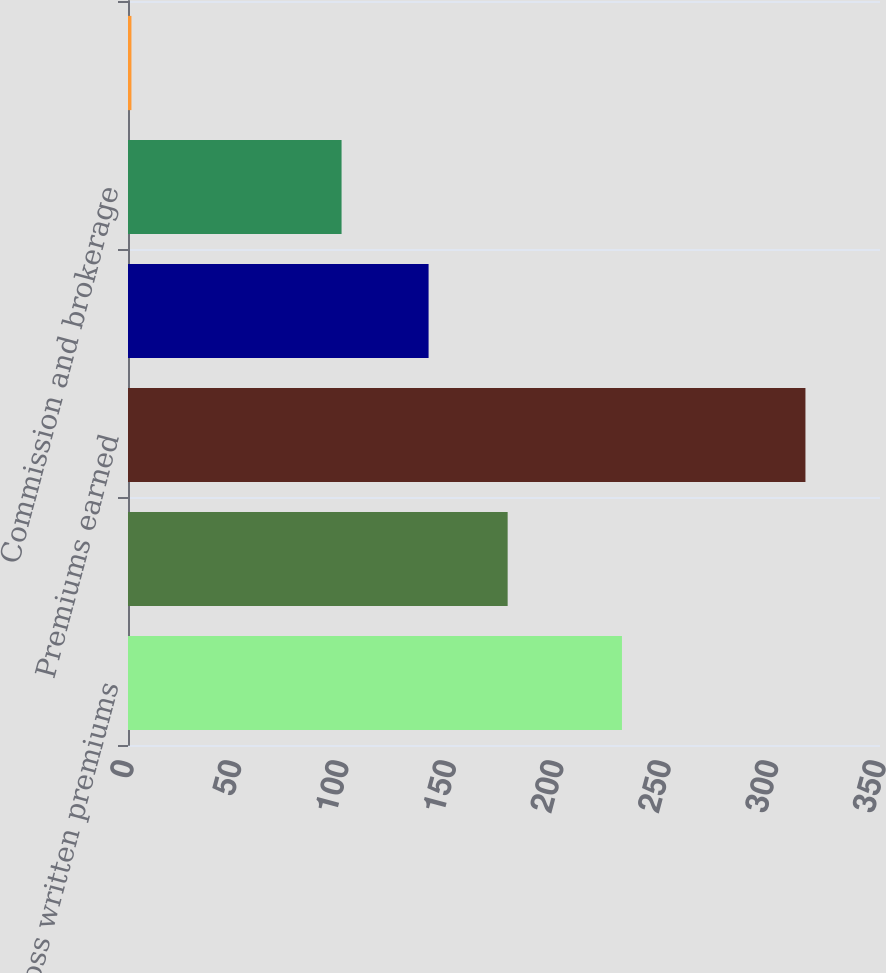Convert chart to OTSL. <chart><loc_0><loc_0><loc_500><loc_500><bar_chart><fcel>Gross written premiums<fcel>Net written premiums<fcel>Premiums earned<fcel>Incurred losses and LAE<fcel>Commission and brokerage<fcel>Other underwriting expenses<nl><fcel>229.9<fcel>176.7<fcel>315.3<fcel>139.9<fcel>99.4<fcel>1.6<nl></chart> 